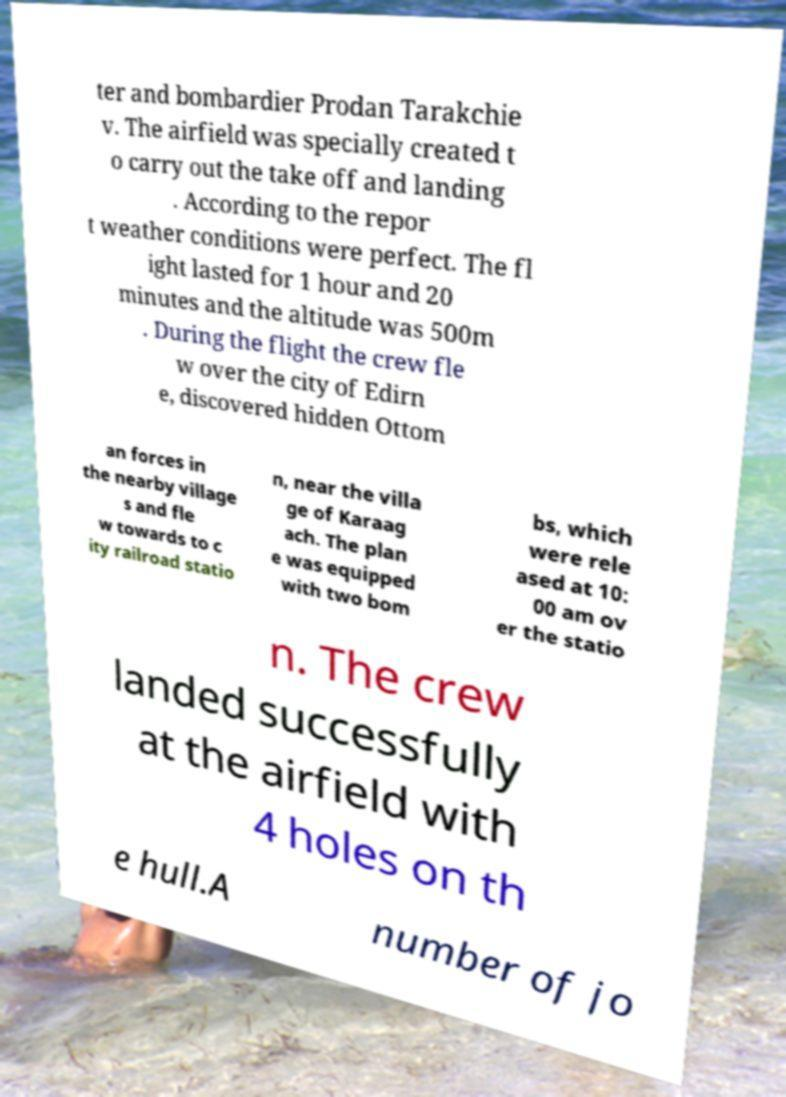Could you extract and type out the text from this image? ter and bombardier Prodan Tarakchie v. The airfield was specially created t o carry out the take off and landing . According to the repor t weather conditions were perfect. The fl ight lasted for 1 hour and 20 minutes and the altitude was 500m . During the flight the crew fle w over the city of Edirn e, discovered hidden Ottom an forces in the nearby village s and fle w towards to c ity railroad statio n, near the villa ge of Karaag ach. The plan e was equipped with two bom bs, which were rele ased at 10: 00 am ov er the statio n. The crew landed successfully at the airfield with 4 holes on th e hull.A number of jo 